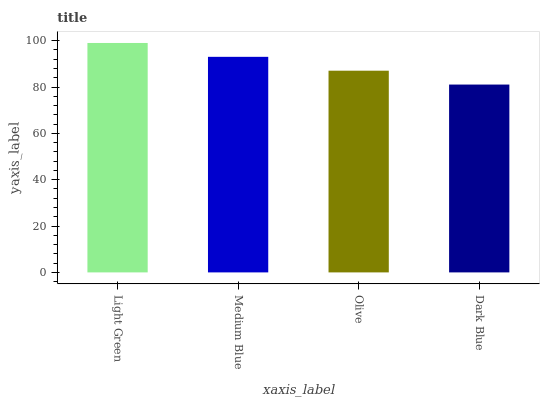Is Dark Blue the minimum?
Answer yes or no. Yes. Is Light Green the maximum?
Answer yes or no. Yes. Is Medium Blue the minimum?
Answer yes or no. No. Is Medium Blue the maximum?
Answer yes or no. No. Is Light Green greater than Medium Blue?
Answer yes or no. Yes. Is Medium Blue less than Light Green?
Answer yes or no. Yes. Is Medium Blue greater than Light Green?
Answer yes or no. No. Is Light Green less than Medium Blue?
Answer yes or no. No. Is Medium Blue the high median?
Answer yes or no. Yes. Is Olive the low median?
Answer yes or no. Yes. Is Olive the high median?
Answer yes or no. No. Is Dark Blue the low median?
Answer yes or no. No. 